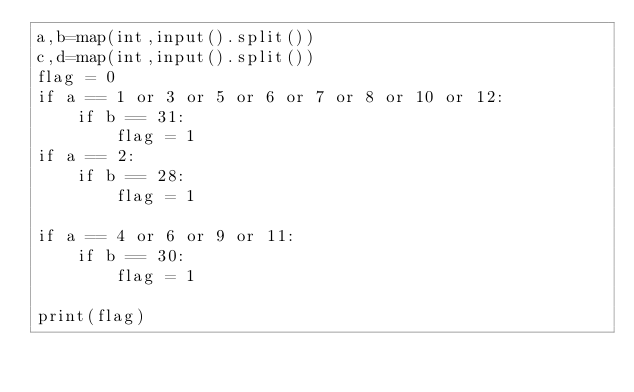<code> <loc_0><loc_0><loc_500><loc_500><_Python_>a,b=map(int,input().split())
c,d=map(int,input().split())
flag = 0
if a == 1 or 3 or 5 or 6 or 7 or 8 or 10 or 12:
    if b == 31:
        flag = 1
if a == 2:
    if b == 28:
        flag = 1

if a == 4 or 6 or 9 or 11:
    if b == 30:
        flag = 1

print(flag)</code> 